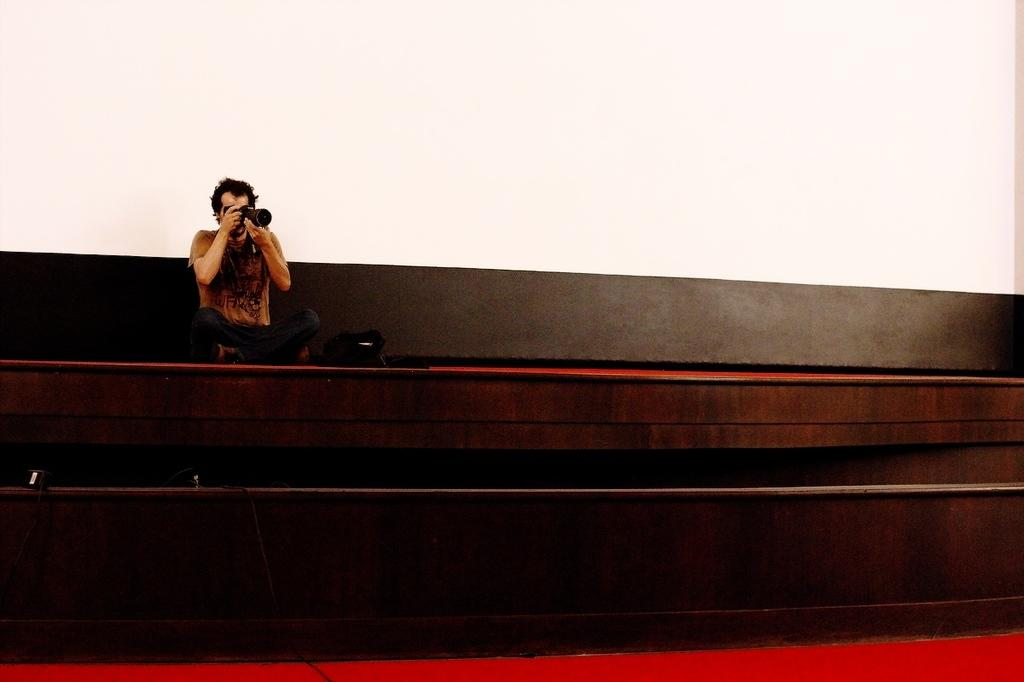Who is present in the image? There is a man in the image. What is the man doing in the image? The man is sitting on wooden stairs and taking a photograph with a camera. What is located beside the man? There is a bag beside the man. What type of toy can be seen in the man's hand in the image? There is no toy present in the man's hand in the image; he is holding a camera. 